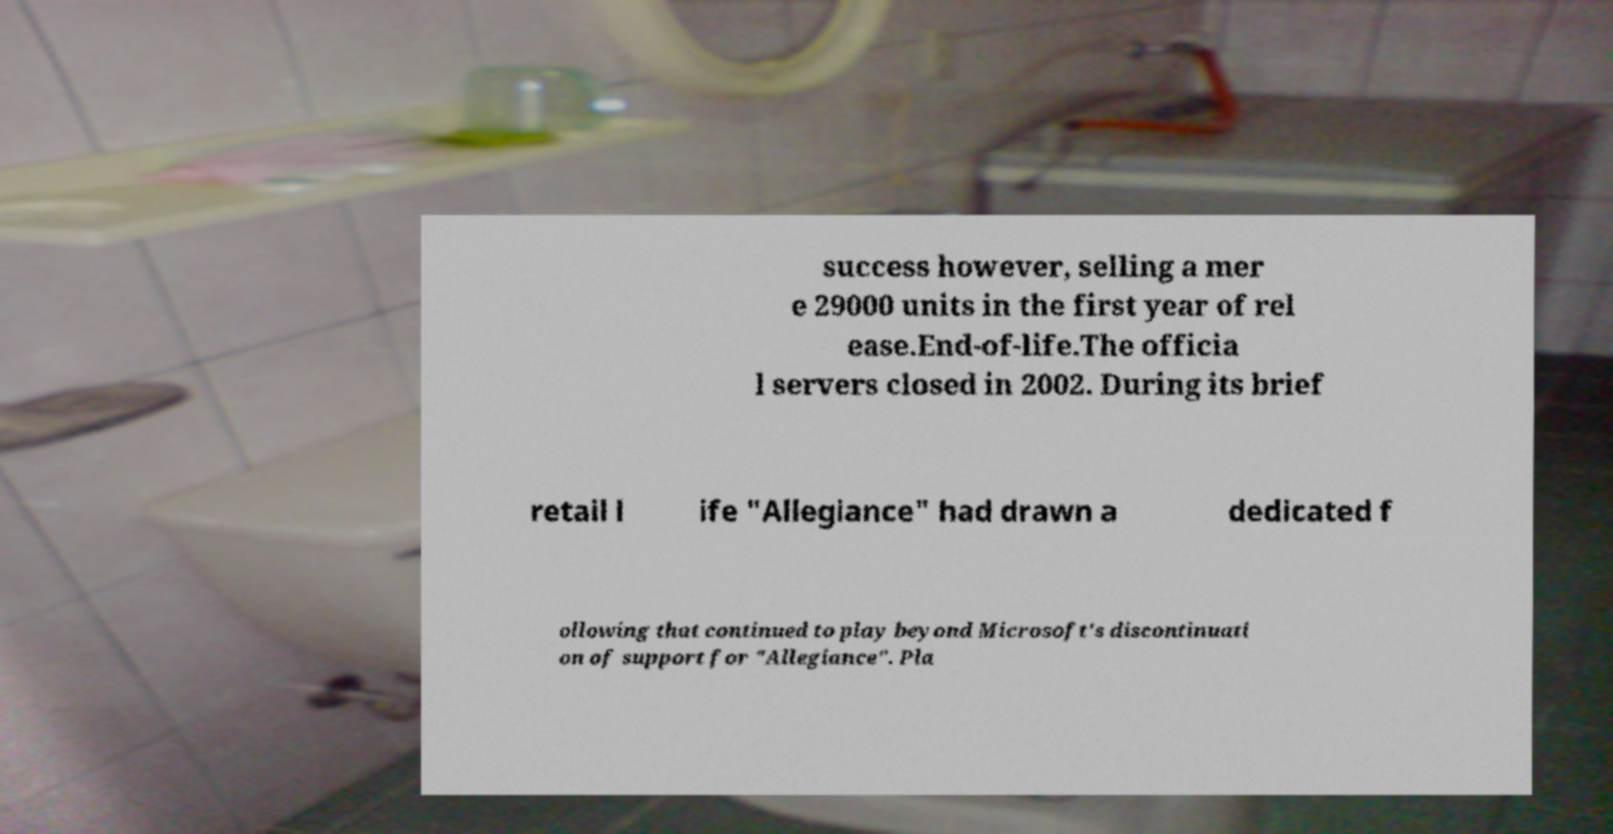For documentation purposes, I need the text within this image transcribed. Could you provide that? success however, selling a mer e 29000 units in the first year of rel ease.End-of-life.The officia l servers closed in 2002. During its brief retail l ife "Allegiance" had drawn a dedicated f ollowing that continued to play beyond Microsoft's discontinuati on of support for "Allegiance". Pla 